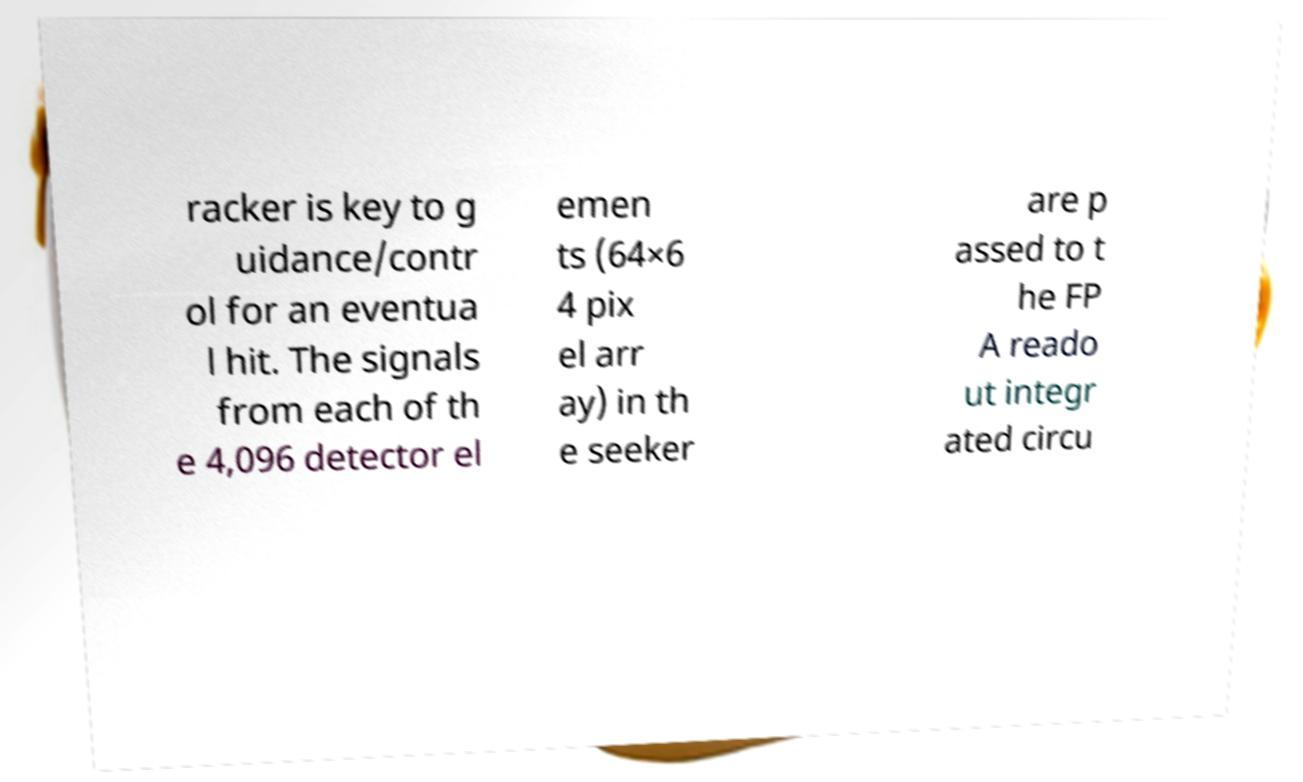For documentation purposes, I need the text within this image transcribed. Could you provide that? racker is key to g uidance/contr ol for an eventua l hit. The signals from each of th e 4,096 detector el emen ts (64×6 4 pix el arr ay) in th e seeker are p assed to t he FP A reado ut integr ated circu 